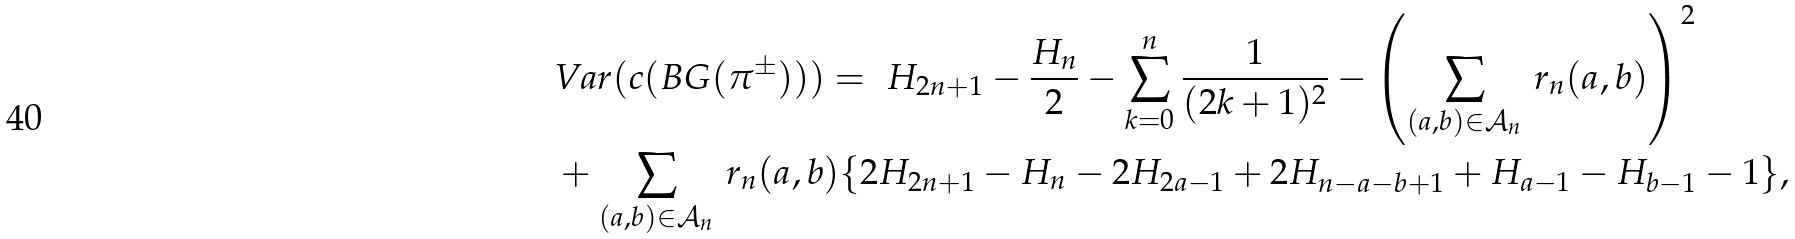Convert formula to latex. <formula><loc_0><loc_0><loc_500><loc_500>& V a r ( c ( B G ( \pi ^ { \pm } ) ) ) = \ H _ { 2 n + 1 } - \frac { H _ { n } } { 2 } - \sum _ { k = 0 } ^ { n } \frac { 1 } { ( 2 k + 1 ) ^ { 2 } } - \left ( \sum _ { ( a , b ) \in \mathcal { A } _ { n } } \, r _ { n } ( a , b ) \right ) ^ { 2 } \\ & + \sum _ { ( a , b ) \in \mathcal { A } _ { n } } \, r _ { n } ( a , b ) \{ 2 H _ { 2 n + 1 } - H _ { n } - 2 H _ { 2 a - 1 } + 2 H _ { n - a - b + 1 } + H _ { a - 1 } - H _ { b - 1 } - 1 \} ,</formula> 